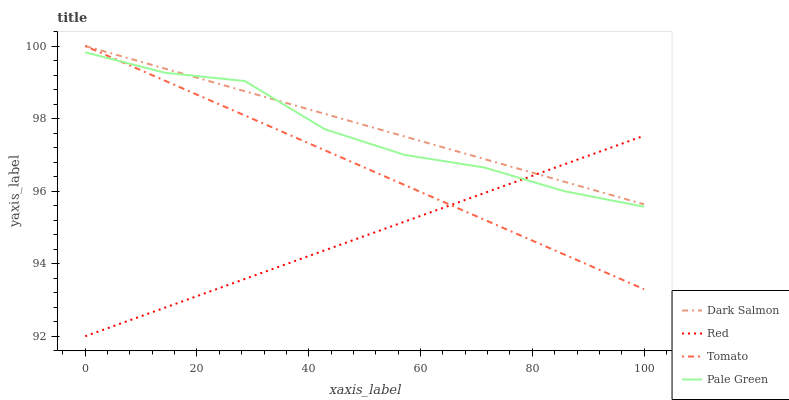Does Pale Green have the minimum area under the curve?
Answer yes or no. No. Does Pale Green have the maximum area under the curve?
Answer yes or no. No. Is Dark Salmon the smoothest?
Answer yes or no. No. Is Dark Salmon the roughest?
Answer yes or no. No. Does Pale Green have the lowest value?
Answer yes or no. No. Does Pale Green have the highest value?
Answer yes or no. No. 